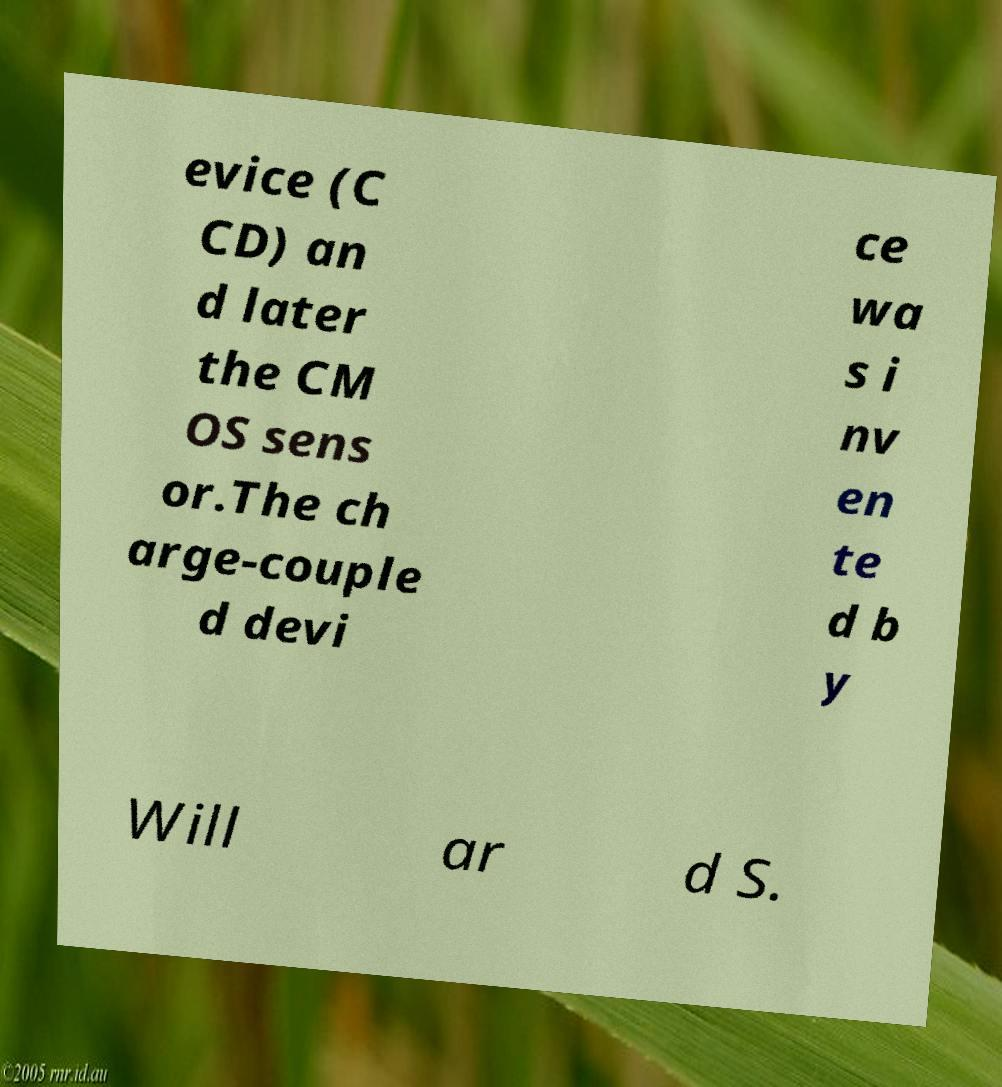I need the written content from this picture converted into text. Can you do that? evice (C CD) an d later the CM OS sens or.The ch arge-couple d devi ce wa s i nv en te d b y Will ar d S. 